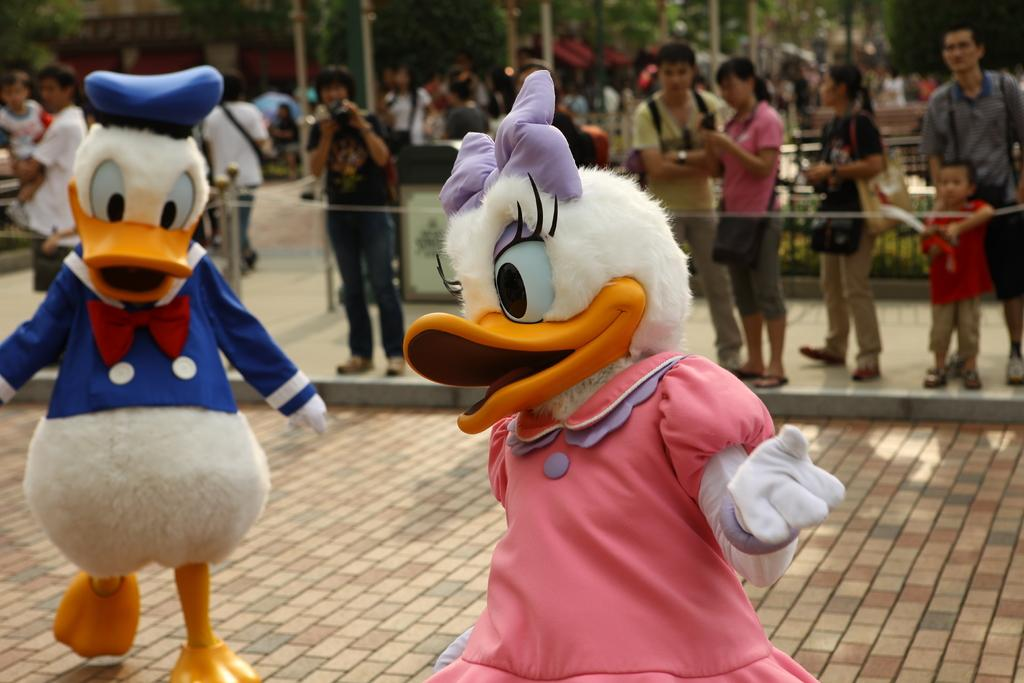What are the two persons in the image wearing? The two persons in the image are wearing costumes. Can you describe the people in the background of the image? There are people standing in the background of the image. What objects can be seen in the image besides the persons in costumes? There are poles visible in the image. What type of natural scenery is visible in the background of the image? There are trees in the background of the image. How would you describe the overall clarity of the image? The image is blurred. What type of bubble is floating in the air in the image? There is no bubble floating in the air in the image. What type of mine is visible in the background of the image? There is no mine visible in the image; it features trees in the background. 